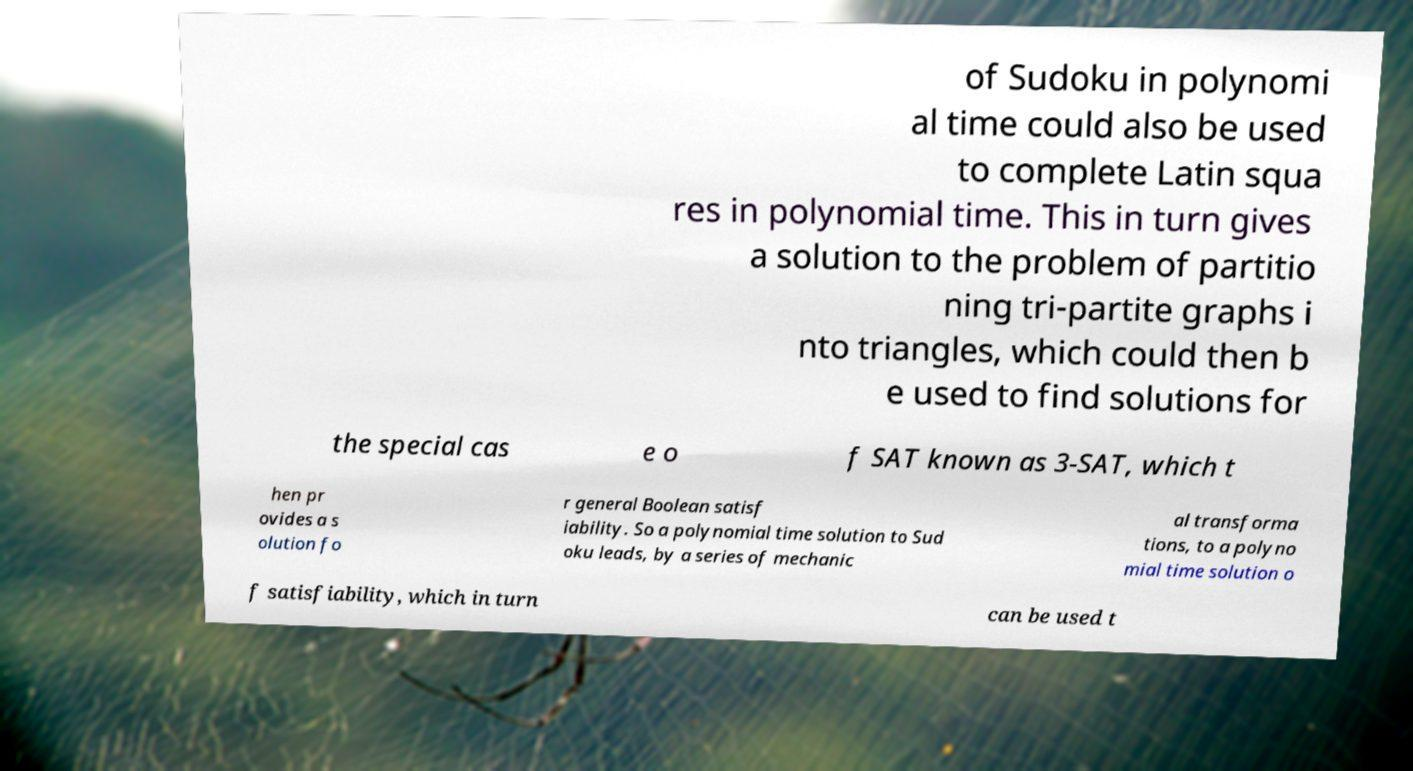Could you extract and type out the text from this image? of Sudoku in polynomi al time could also be used to complete Latin squa res in polynomial time. This in turn gives a solution to the problem of partitio ning tri-partite graphs i nto triangles, which could then b e used to find solutions for the special cas e o f SAT known as 3-SAT, which t hen pr ovides a s olution fo r general Boolean satisf iability. So a polynomial time solution to Sud oku leads, by a series of mechanic al transforma tions, to a polyno mial time solution o f satisfiability, which in turn can be used t 